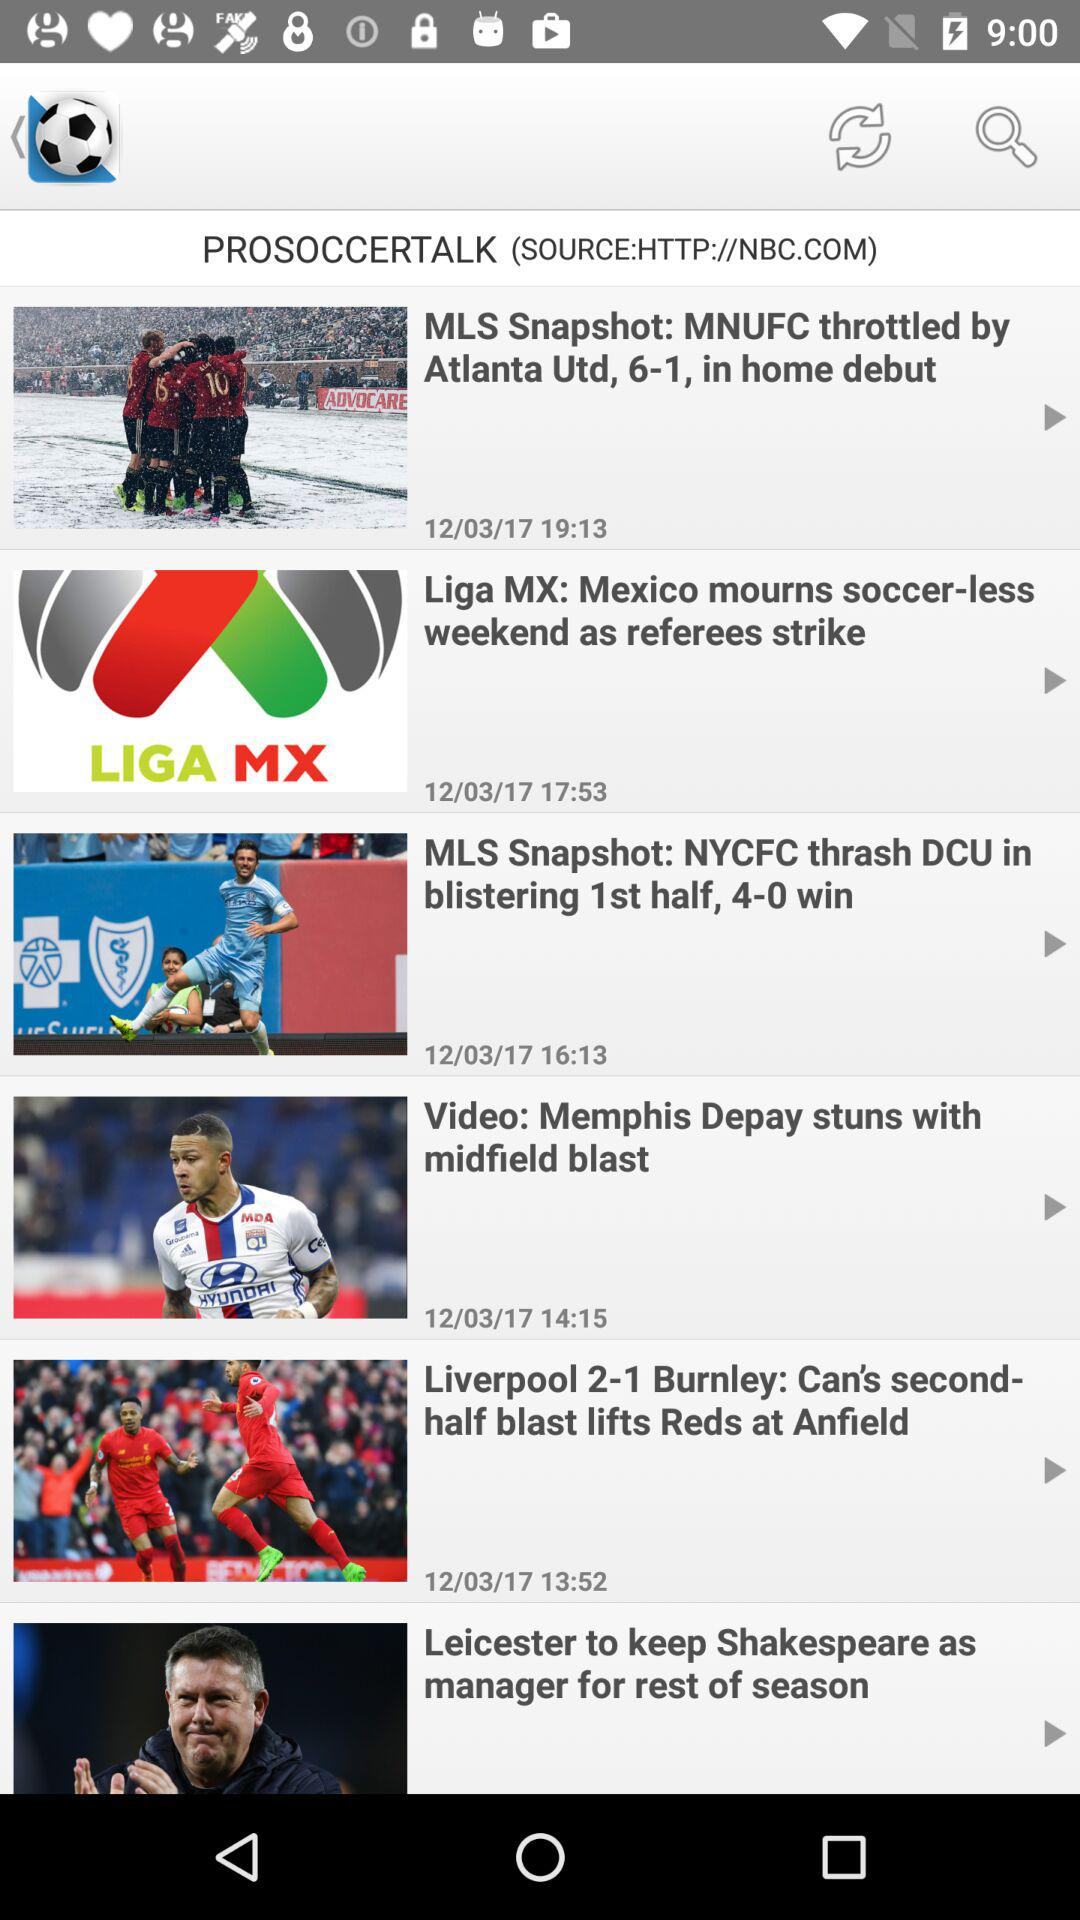What is the winning score of the NYCFC? The winning score of the NYCFC is 4-0. 